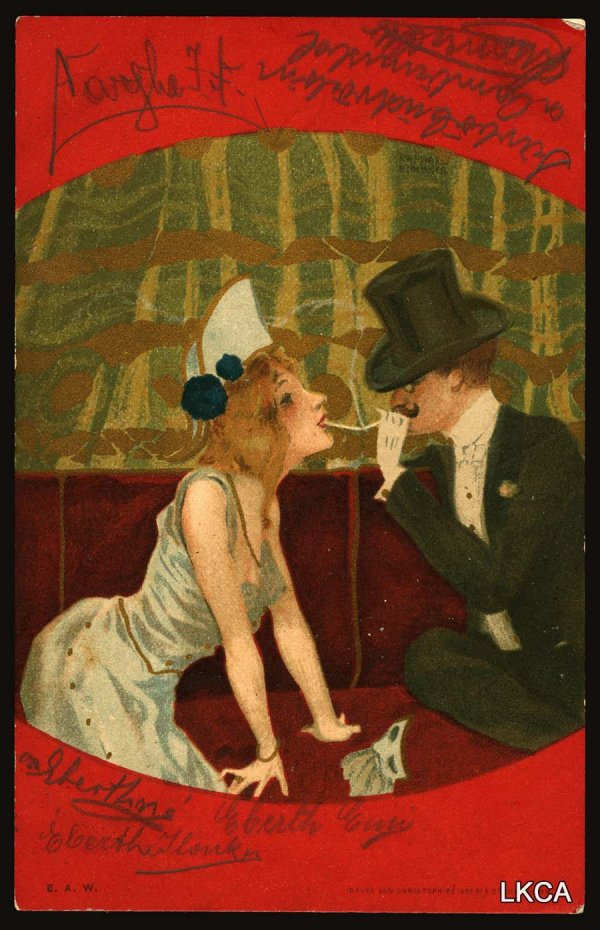Create a concise poem inspired by this image. In silken threads of twilight’s gleam,
Two hearts converge in whispered dream.
With top hat high and dress of white,
They meet on velvet’s crimson light.
In hues of passion, love's sweet art,
‘May all hearts glow,’ as ours impart. 